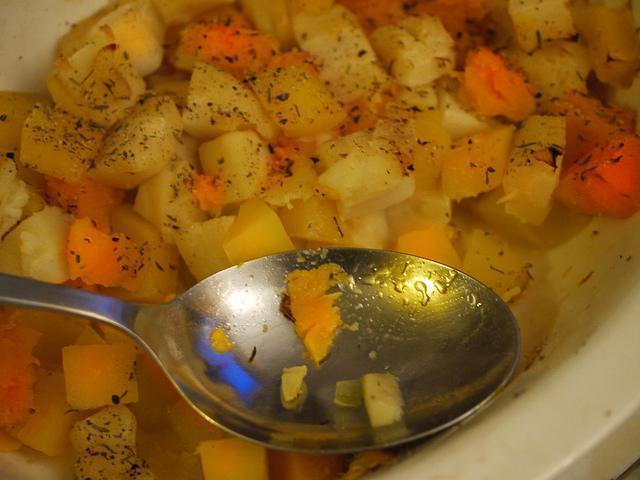How many spoons are there?
Give a very brief answer. 1. How many carrots are visible?
Give a very brief answer. 4. 